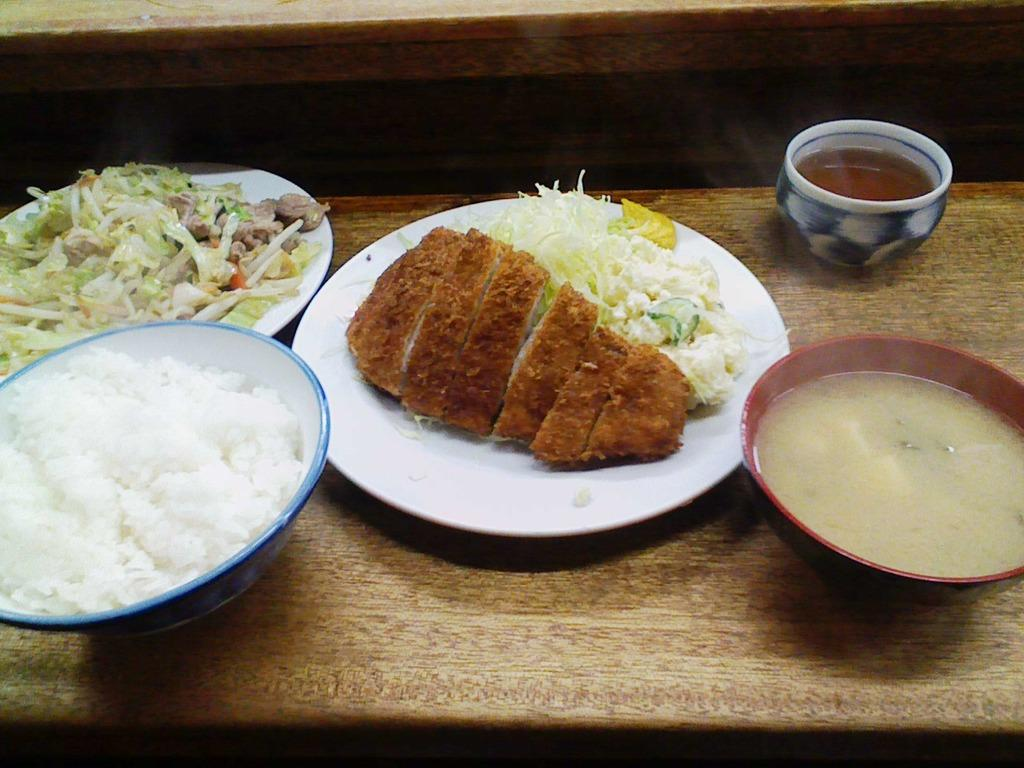What types of dishes are present in the image? There are plates and bowls in the image. What other type of container is visible in the image? There is a cup in the image. What is inside the dishes and cup? There is food in the image. What is the surface on which the dishes and cup are placed? The objects are on a wooden platform. What grade does the kettle receive for its performance in the image? There is no kettle present in the image, so it cannot receive a grade for its performance. 